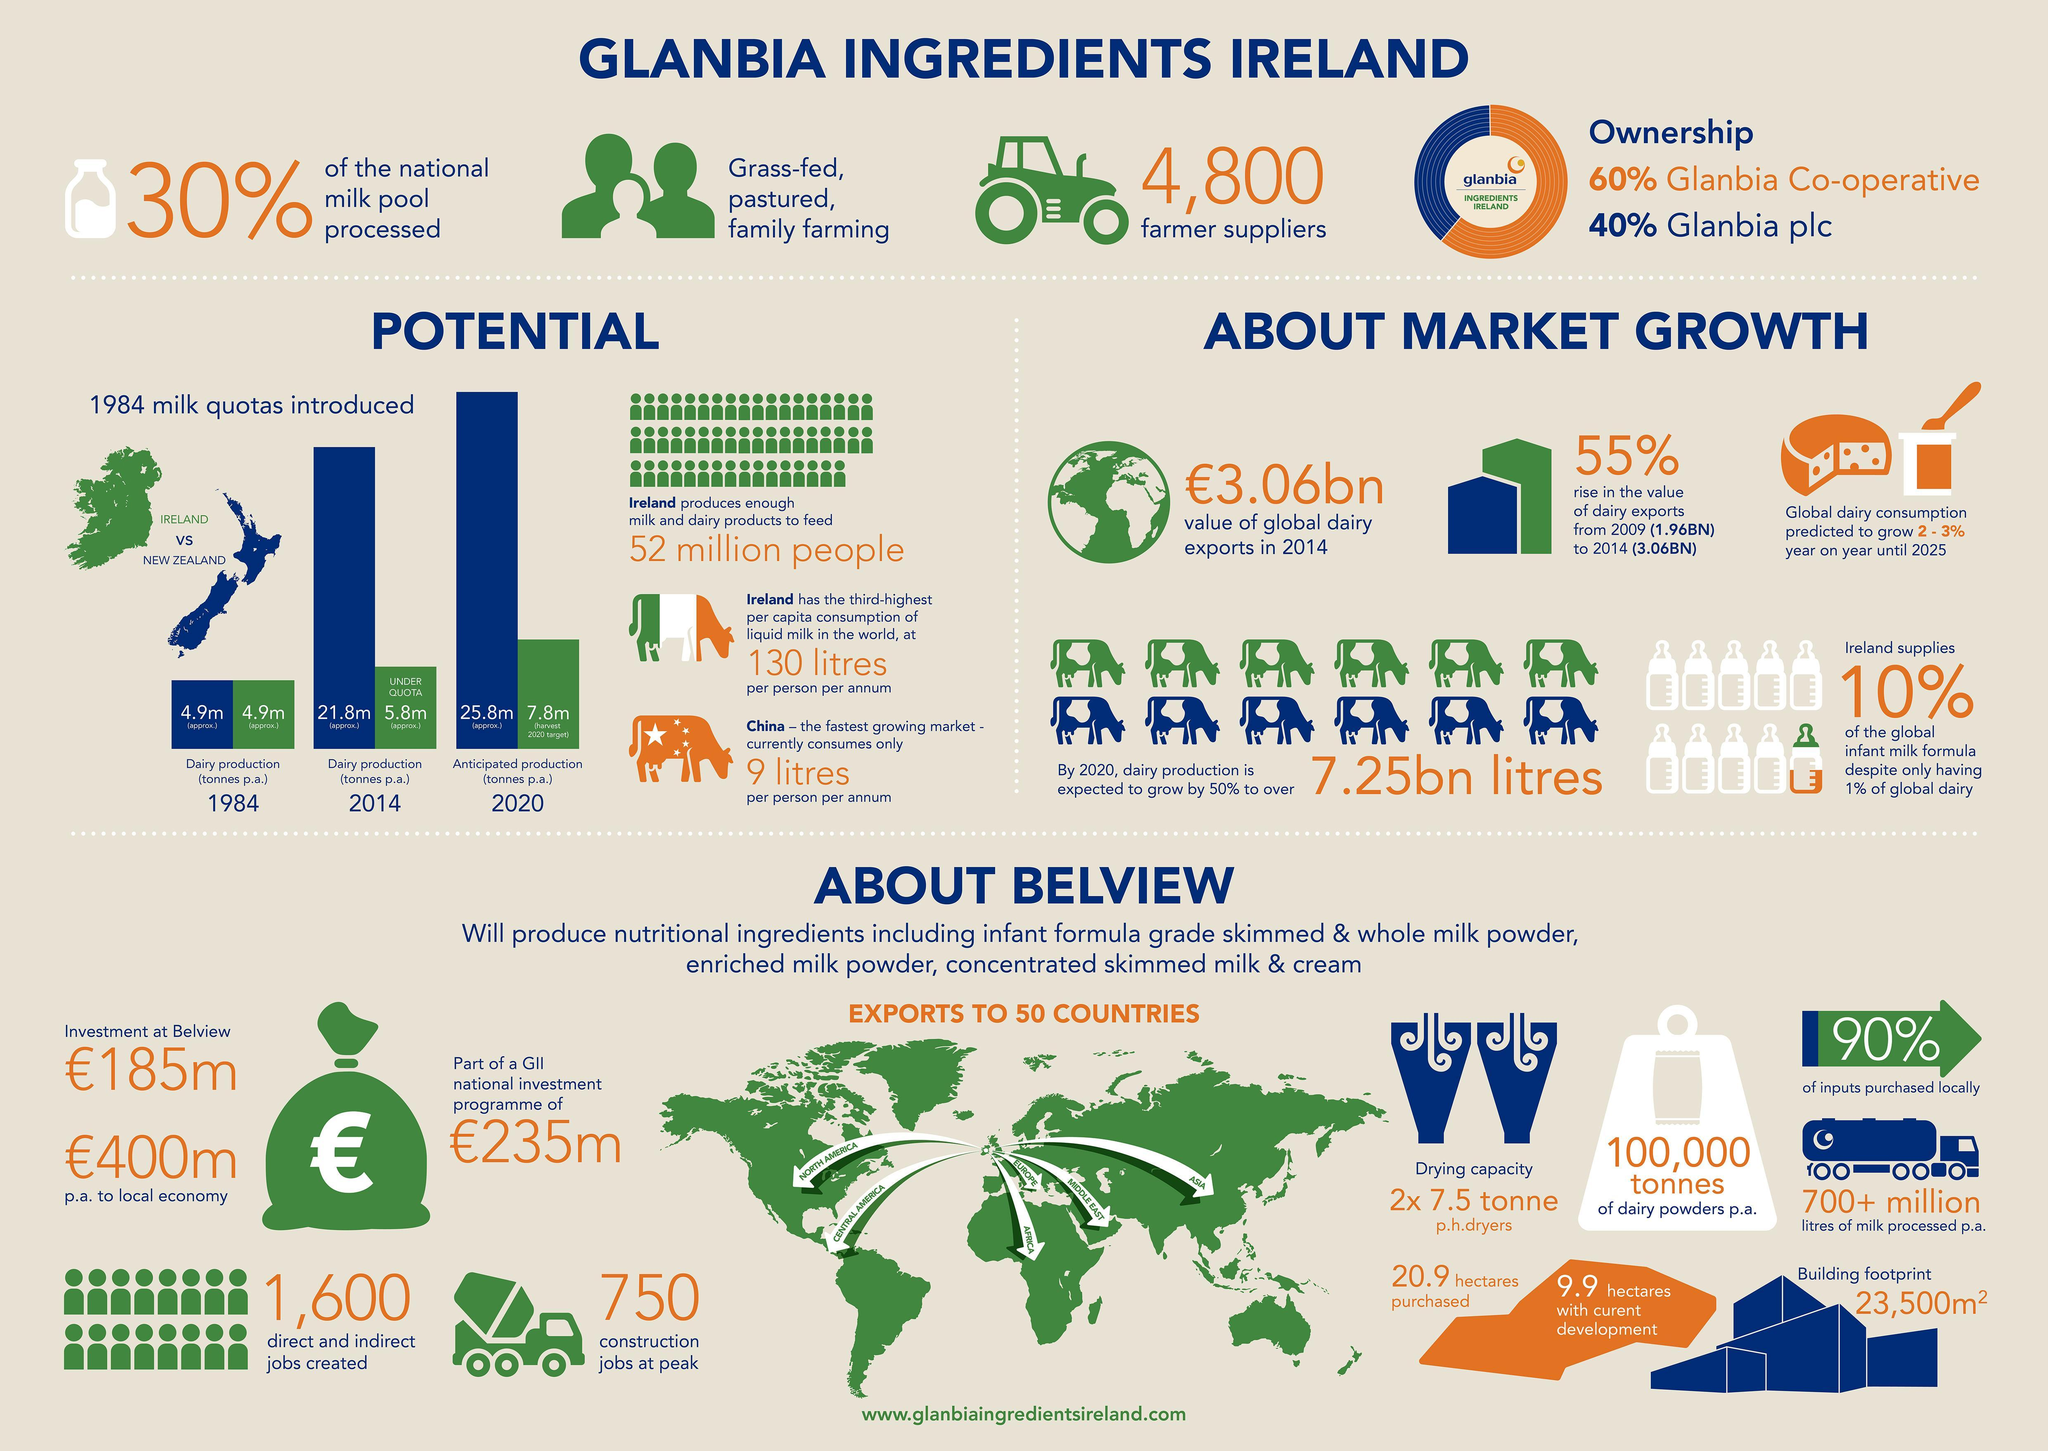what is the average of amount of milk production expected (in million tonnes) by New Zealand and Ireland in 2020 as per the bar chart?
Answer the question with a short phrase. 16.8 what is the average of amount of milk produced (in million tonnes) by New Zealand and Ireland in 2014 as per the bar chart? 13.8 what is the total amount of milk produced (in million tonnes) by new Zealand in 1984 as per the bar chart? 4.9m what is the total amount of milk produced (in million tonnes) by Ireland in 2014 as per the bar chart? 5.8m what is the total amount of milk produced (in million tonnes) by New Zealand in 2014 as per the bar chart? 21.8 what is the total amount of milk produced (in million tonnes) by Ireland in 1984 as per the bar chart? 4.9m 